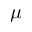Convert formula to latex. <formula><loc_0><loc_0><loc_500><loc_500>\mu</formula> 